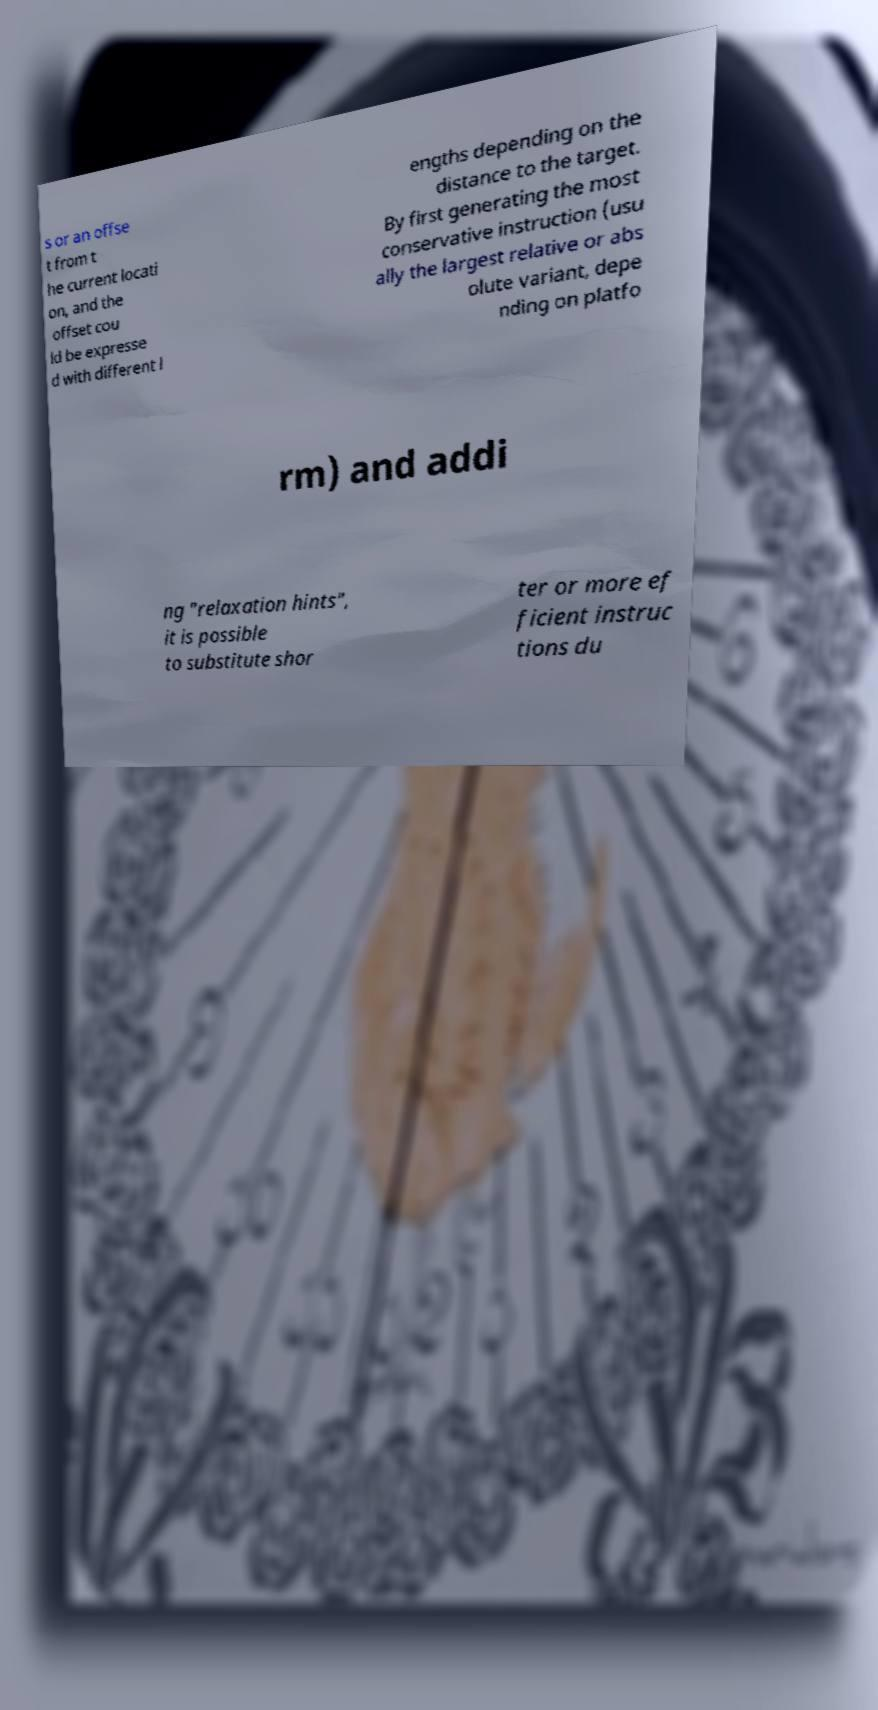Can you accurately transcribe the text from the provided image for me? s or an offse t from t he current locati on, and the offset cou ld be expresse d with different l engths depending on the distance to the target. By first generating the most conservative instruction (usu ally the largest relative or abs olute variant, depe nding on platfo rm) and addi ng "relaxation hints", it is possible to substitute shor ter or more ef ficient instruc tions du 